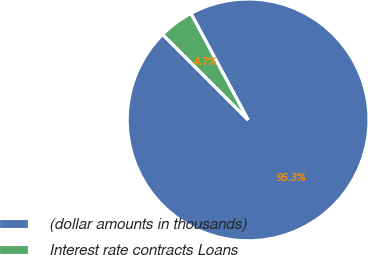Convert chart to OTSL. <chart><loc_0><loc_0><loc_500><loc_500><pie_chart><fcel>(dollar amounts in thousands)<fcel>Interest rate contracts Loans<nl><fcel>95.35%<fcel>4.65%<nl></chart> 